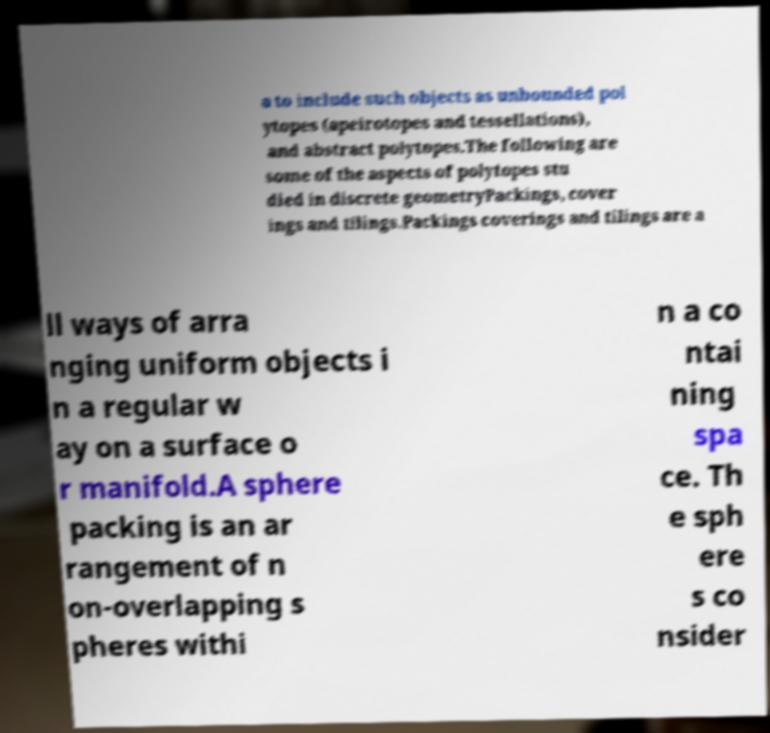Could you assist in decoding the text presented in this image and type it out clearly? a to include such objects as unbounded pol ytopes (apeirotopes and tessellations), and abstract polytopes.The following are some of the aspects of polytopes stu died in discrete geometryPackings, cover ings and tilings.Packings coverings and tilings are a ll ways of arra nging uniform objects i n a regular w ay on a surface o r manifold.A sphere packing is an ar rangement of n on-overlapping s pheres withi n a co ntai ning spa ce. Th e sph ere s co nsider 